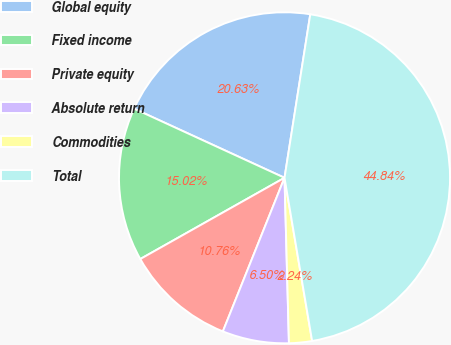<chart> <loc_0><loc_0><loc_500><loc_500><pie_chart><fcel>Global equity<fcel>Fixed income<fcel>Private equity<fcel>Absolute return<fcel>Commodities<fcel>Total<nl><fcel>20.63%<fcel>15.02%<fcel>10.76%<fcel>6.5%<fcel>2.24%<fcel>44.84%<nl></chart> 